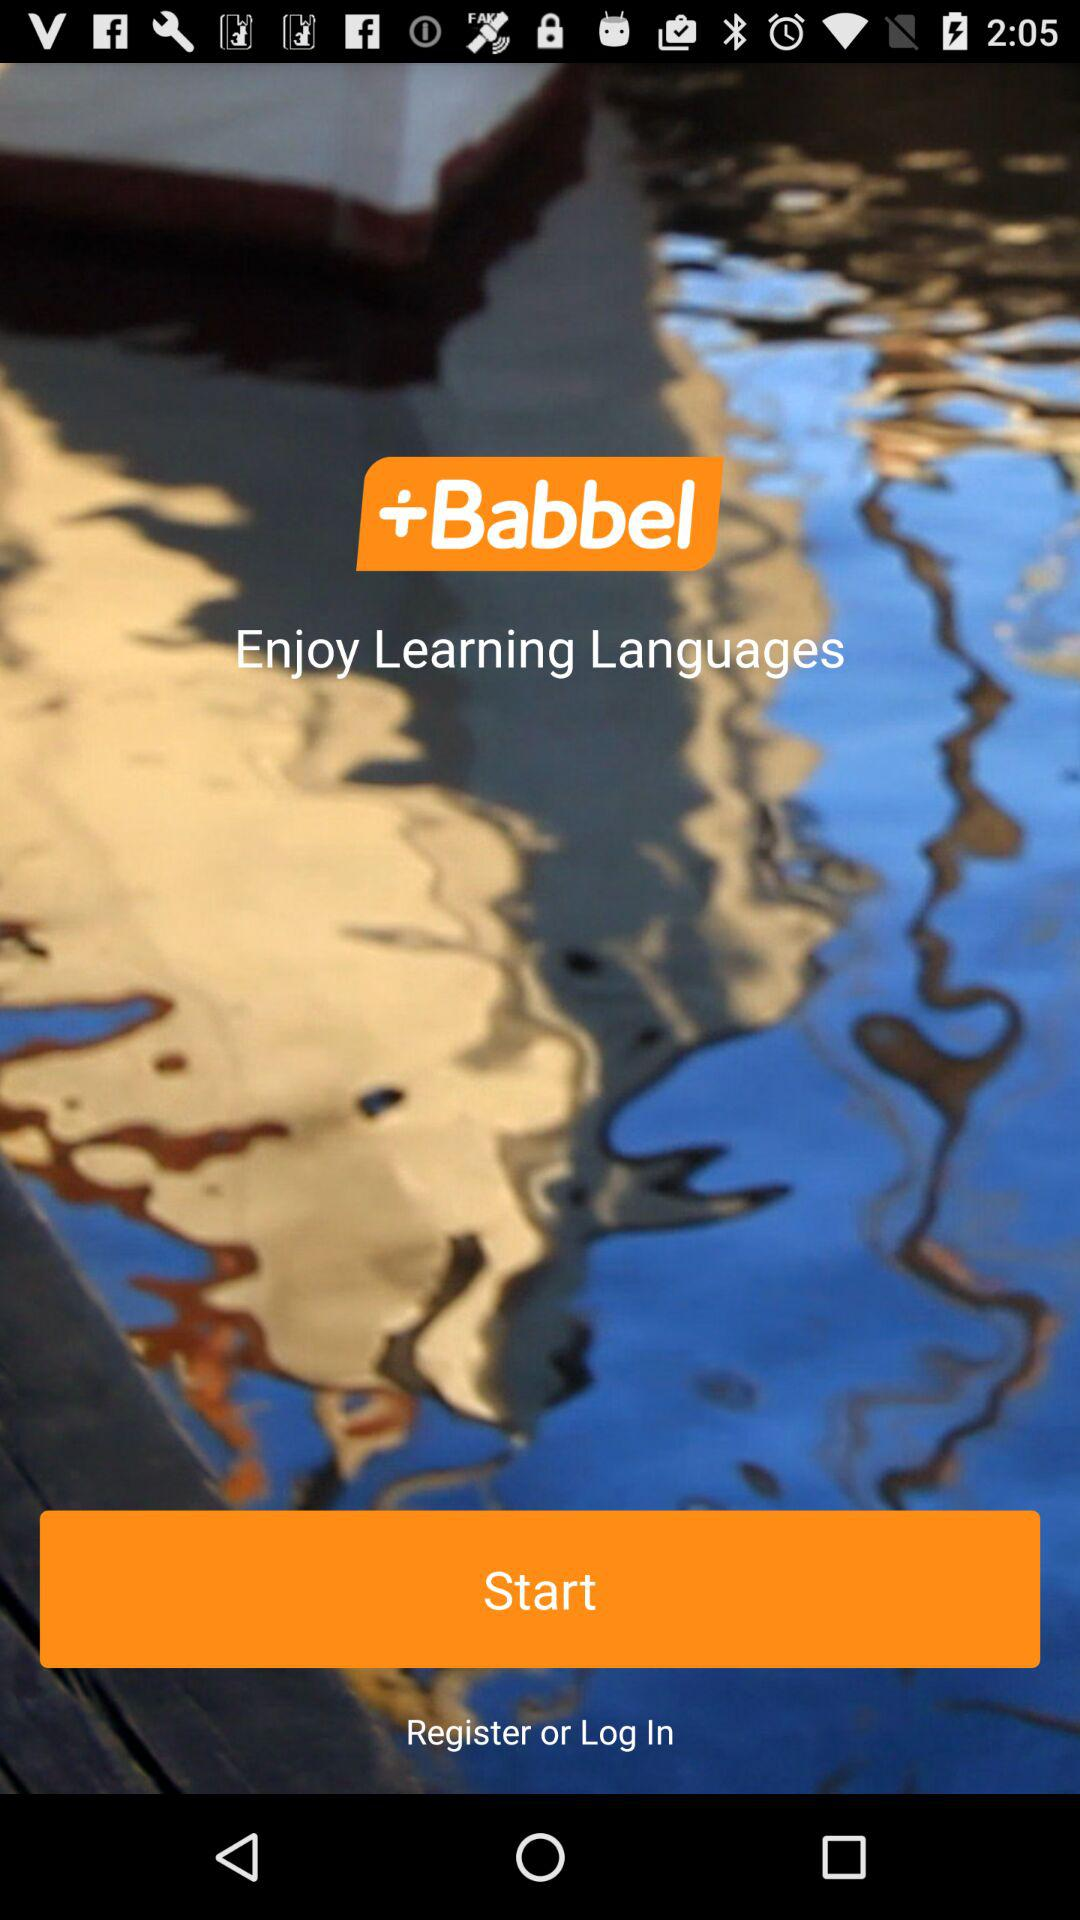What is the application name? The application name is "Babbel". 